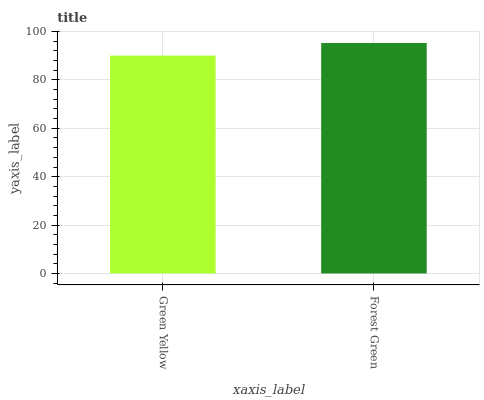Is Green Yellow the minimum?
Answer yes or no. Yes. Is Forest Green the maximum?
Answer yes or no. Yes. Is Forest Green the minimum?
Answer yes or no. No. Is Forest Green greater than Green Yellow?
Answer yes or no. Yes. Is Green Yellow less than Forest Green?
Answer yes or no. Yes. Is Green Yellow greater than Forest Green?
Answer yes or no. No. Is Forest Green less than Green Yellow?
Answer yes or no. No. Is Forest Green the high median?
Answer yes or no. Yes. Is Green Yellow the low median?
Answer yes or no. Yes. Is Green Yellow the high median?
Answer yes or no. No. Is Forest Green the low median?
Answer yes or no. No. 